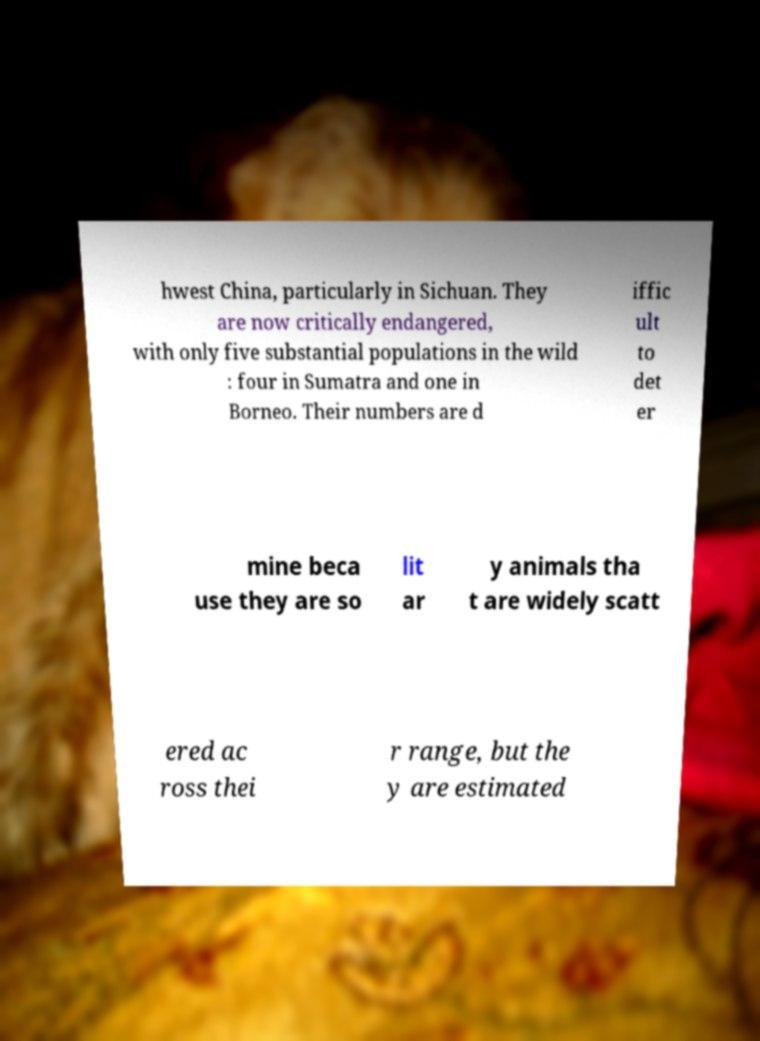Can you accurately transcribe the text from the provided image for me? hwest China, particularly in Sichuan. They are now critically endangered, with only five substantial populations in the wild : four in Sumatra and one in Borneo. Their numbers are d iffic ult to det er mine beca use they are so lit ar y animals tha t are widely scatt ered ac ross thei r range, but the y are estimated 